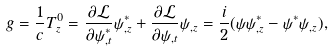Convert formula to latex. <formula><loc_0><loc_0><loc_500><loc_500>g = \frac { 1 } { c } T ^ { 0 } _ { z } = \frac { \partial \mathcal { L } } { \partial \psi ^ { * } _ { , t } } \psi ^ { * } _ { , z } + \frac { \partial \mathcal { L } } { \partial \psi _ { , t } } \psi _ { , z } = \frac { i } { 2 } ( \psi \psi ^ { * } _ { , z } - \psi ^ { * } \psi _ { , z } ) ,</formula> 